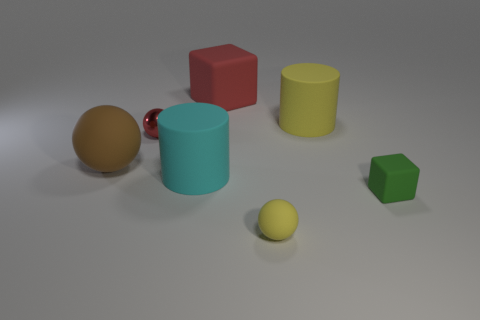Subtract all red spheres. How many spheres are left? 2 Subtract 1 blocks. How many blocks are left? 1 Add 2 red shiny cubes. How many objects exist? 9 Subtract all red cubes. How many cubes are left? 1 Subtract all cylinders. How many objects are left? 5 Subtract all red cubes. Subtract all big red things. How many objects are left? 5 Add 5 small red shiny spheres. How many small red shiny spheres are left? 6 Add 5 large gray cubes. How many large gray cubes exist? 5 Subtract 0 gray spheres. How many objects are left? 7 Subtract all blue spheres. Subtract all brown cubes. How many spheres are left? 3 